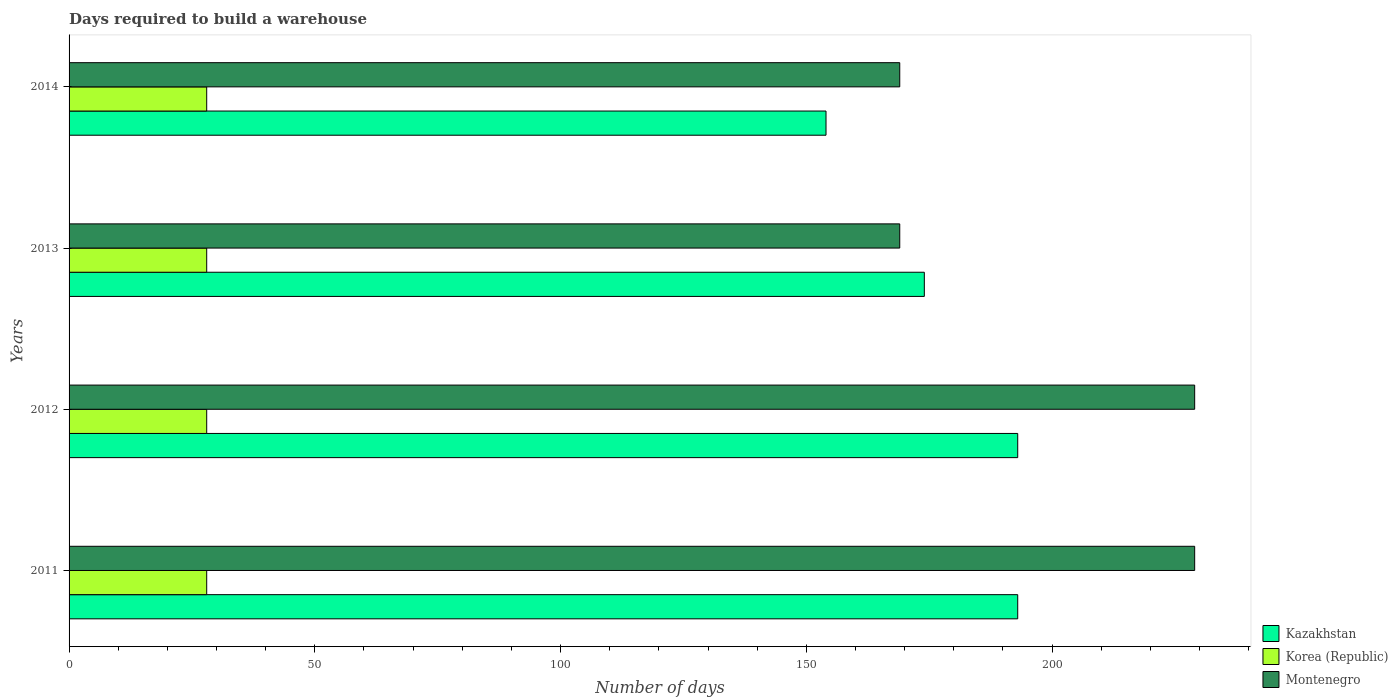Are the number of bars on each tick of the Y-axis equal?
Offer a very short reply. Yes. How many bars are there on the 2nd tick from the bottom?
Your answer should be very brief. 3. What is the label of the 2nd group of bars from the top?
Give a very brief answer. 2013. What is the days required to build a warehouse in in Korea (Republic) in 2014?
Offer a very short reply. 28. Across all years, what is the maximum days required to build a warehouse in in Kazakhstan?
Your response must be concise. 193. Across all years, what is the minimum days required to build a warehouse in in Montenegro?
Make the answer very short. 169. In which year was the days required to build a warehouse in in Kazakhstan maximum?
Ensure brevity in your answer.  2011. What is the total days required to build a warehouse in in Korea (Republic) in the graph?
Your answer should be very brief. 112. What is the difference between the days required to build a warehouse in in Kazakhstan in 2011 and the days required to build a warehouse in in Montenegro in 2013?
Your answer should be compact. 24. What is the average days required to build a warehouse in in Montenegro per year?
Your response must be concise. 199. In the year 2013, what is the difference between the days required to build a warehouse in in Montenegro and days required to build a warehouse in in Korea (Republic)?
Make the answer very short. 141. In how many years, is the days required to build a warehouse in in Korea (Republic) greater than 160 days?
Ensure brevity in your answer.  0. What is the ratio of the days required to build a warehouse in in Kazakhstan in 2012 to that in 2013?
Make the answer very short. 1.11. Is the days required to build a warehouse in in Montenegro in 2012 less than that in 2014?
Provide a succinct answer. No. What is the difference between the highest and the lowest days required to build a warehouse in in Kazakhstan?
Your answer should be very brief. 39. In how many years, is the days required to build a warehouse in in Montenegro greater than the average days required to build a warehouse in in Montenegro taken over all years?
Ensure brevity in your answer.  2. What does the 1st bar from the bottom in 2011 represents?
Give a very brief answer. Kazakhstan. Is it the case that in every year, the sum of the days required to build a warehouse in in Kazakhstan and days required to build a warehouse in in Montenegro is greater than the days required to build a warehouse in in Korea (Republic)?
Offer a very short reply. Yes. How many bars are there?
Ensure brevity in your answer.  12. Are all the bars in the graph horizontal?
Your response must be concise. Yes. Are the values on the major ticks of X-axis written in scientific E-notation?
Ensure brevity in your answer.  No. Does the graph contain any zero values?
Ensure brevity in your answer.  No. How are the legend labels stacked?
Provide a short and direct response. Vertical. What is the title of the graph?
Provide a succinct answer. Days required to build a warehouse. What is the label or title of the X-axis?
Provide a succinct answer. Number of days. What is the Number of days of Kazakhstan in 2011?
Your response must be concise. 193. What is the Number of days in Korea (Republic) in 2011?
Ensure brevity in your answer.  28. What is the Number of days in Montenegro in 2011?
Provide a succinct answer. 229. What is the Number of days in Kazakhstan in 2012?
Offer a terse response. 193. What is the Number of days in Montenegro in 2012?
Offer a terse response. 229. What is the Number of days of Kazakhstan in 2013?
Offer a very short reply. 174. What is the Number of days of Korea (Republic) in 2013?
Your answer should be compact. 28. What is the Number of days in Montenegro in 2013?
Provide a short and direct response. 169. What is the Number of days of Kazakhstan in 2014?
Make the answer very short. 154. What is the Number of days of Korea (Republic) in 2014?
Your answer should be very brief. 28. What is the Number of days of Montenegro in 2014?
Your answer should be very brief. 169. Across all years, what is the maximum Number of days in Kazakhstan?
Ensure brevity in your answer.  193. Across all years, what is the maximum Number of days of Korea (Republic)?
Give a very brief answer. 28. Across all years, what is the maximum Number of days of Montenegro?
Offer a very short reply. 229. Across all years, what is the minimum Number of days in Kazakhstan?
Offer a very short reply. 154. Across all years, what is the minimum Number of days of Korea (Republic)?
Provide a short and direct response. 28. Across all years, what is the minimum Number of days of Montenegro?
Your answer should be compact. 169. What is the total Number of days of Kazakhstan in the graph?
Offer a very short reply. 714. What is the total Number of days of Korea (Republic) in the graph?
Your answer should be very brief. 112. What is the total Number of days in Montenegro in the graph?
Your answer should be compact. 796. What is the difference between the Number of days in Kazakhstan in 2011 and that in 2012?
Offer a terse response. 0. What is the difference between the Number of days of Montenegro in 2011 and that in 2012?
Make the answer very short. 0. What is the difference between the Number of days of Korea (Republic) in 2011 and that in 2013?
Offer a very short reply. 0. What is the difference between the Number of days in Montenegro in 2011 and that in 2013?
Your response must be concise. 60. What is the difference between the Number of days in Montenegro in 2011 and that in 2014?
Ensure brevity in your answer.  60. What is the difference between the Number of days in Montenegro in 2012 and that in 2013?
Give a very brief answer. 60. What is the difference between the Number of days in Kazakhstan in 2012 and that in 2014?
Offer a terse response. 39. What is the difference between the Number of days of Korea (Republic) in 2012 and that in 2014?
Offer a very short reply. 0. What is the difference between the Number of days in Montenegro in 2012 and that in 2014?
Offer a very short reply. 60. What is the difference between the Number of days of Kazakhstan in 2013 and that in 2014?
Offer a terse response. 20. What is the difference between the Number of days of Korea (Republic) in 2013 and that in 2014?
Make the answer very short. 0. What is the difference between the Number of days of Kazakhstan in 2011 and the Number of days of Korea (Republic) in 2012?
Give a very brief answer. 165. What is the difference between the Number of days in Kazakhstan in 2011 and the Number of days in Montenegro in 2012?
Your response must be concise. -36. What is the difference between the Number of days in Korea (Republic) in 2011 and the Number of days in Montenegro in 2012?
Offer a terse response. -201. What is the difference between the Number of days in Kazakhstan in 2011 and the Number of days in Korea (Republic) in 2013?
Offer a very short reply. 165. What is the difference between the Number of days of Korea (Republic) in 2011 and the Number of days of Montenegro in 2013?
Your answer should be very brief. -141. What is the difference between the Number of days of Kazakhstan in 2011 and the Number of days of Korea (Republic) in 2014?
Give a very brief answer. 165. What is the difference between the Number of days of Korea (Republic) in 2011 and the Number of days of Montenegro in 2014?
Your answer should be compact. -141. What is the difference between the Number of days of Kazakhstan in 2012 and the Number of days of Korea (Republic) in 2013?
Your answer should be very brief. 165. What is the difference between the Number of days of Kazakhstan in 2012 and the Number of days of Montenegro in 2013?
Your response must be concise. 24. What is the difference between the Number of days of Korea (Republic) in 2012 and the Number of days of Montenegro in 2013?
Provide a short and direct response. -141. What is the difference between the Number of days of Kazakhstan in 2012 and the Number of days of Korea (Republic) in 2014?
Offer a terse response. 165. What is the difference between the Number of days of Korea (Republic) in 2012 and the Number of days of Montenegro in 2014?
Your response must be concise. -141. What is the difference between the Number of days in Kazakhstan in 2013 and the Number of days in Korea (Republic) in 2014?
Your response must be concise. 146. What is the difference between the Number of days in Kazakhstan in 2013 and the Number of days in Montenegro in 2014?
Your answer should be compact. 5. What is the difference between the Number of days of Korea (Republic) in 2013 and the Number of days of Montenegro in 2014?
Make the answer very short. -141. What is the average Number of days in Kazakhstan per year?
Offer a terse response. 178.5. What is the average Number of days in Korea (Republic) per year?
Give a very brief answer. 28. What is the average Number of days in Montenegro per year?
Provide a succinct answer. 199. In the year 2011, what is the difference between the Number of days of Kazakhstan and Number of days of Korea (Republic)?
Your answer should be very brief. 165. In the year 2011, what is the difference between the Number of days in Kazakhstan and Number of days in Montenegro?
Offer a very short reply. -36. In the year 2011, what is the difference between the Number of days in Korea (Republic) and Number of days in Montenegro?
Your answer should be compact. -201. In the year 2012, what is the difference between the Number of days of Kazakhstan and Number of days of Korea (Republic)?
Offer a terse response. 165. In the year 2012, what is the difference between the Number of days in Kazakhstan and Number of days in Montenegro?
Offer a very short reply. -36. In the year 2012, what is the difference between the Number of days in Korea (Republic) and Number of days in Montenegro?
Your answer should be compact. -201. In the year 2013, what is the difference between the Number of days of Kazakhstan and Number of days of Korea (Republic)?
Your answer should be very brief. 146. In the year 2013, what is the difference between the Number of days in Kazakhstan and Number of days in Montenegro?
Provide a succinct answer. 5. In the year 2013, what is the difference between the Number of days of Korea (Republic) and Number of days of Montenegro?
Keep it short and to the point. -141. In the year 2014, what is the difference between the Number of days of Kazakhstan and Number of days of Korea (Republic)?
Your response must be concise. 126. In the year 2014, what is the difference between the Number of days of Korea (Republic) and Number of days of Montenegro?
Ensure brevity in your answer.  -141. What is the ratio of the Number of days in Kazakhstan in 2011 to that in 2013?
Your answer should be very brief. 1.11. What is the ratio of the Number of days of Montenegro in 2011 to that in 2013?
Offer a terse response. 1.35. What is the ratio of the Number of days in Kazakhstan in 2011 to that in 2014?
Ensure brevity in your answer.  1.25. What is the ratio of the Number of days in Montenegro in 2011 to that in 2014?
Ensure brevity in your answer.  1.35. What is the ratio of the Number of days of Kazakhstan in 2012 to that in 2013?
Provide a succinct answer. 1.11. What is the ratio of the Number of days in Korea (Republic) in 2012 to that in 2013?
Your answer should be very brief. 1. What is the ratio of the Number of days of Montenegro in 2012 to that in 2013?
Your answer should be compact. 1.35. What is the ratio of the Number of days of Kazakhstan in 2012 to that in 2014?
Give a very brief answer. 1.25. What is the ratio of the Number of days in Montenegro in 2012 to that in 2014?
Offer a terse response. 1.35. What is the ratio of the Number of days of Kazakhstan in 2013 to that in 2014?
Offer a very short reply. 1.13. What is the ratio of the Number of days in Montenegro in 2013 to that in 2014?
Offer a very short reply. 1. What is the difference between the highest and the second highest Number of days of Kazakhstan?
Your answer should be very brief. 0. What is the difference between the highest and the lowest Number of days of Kazakhstan?
Your response must be concise. 39. What is the difference between the highest and the lowest Number of days in Montenegro?
Offer a very short reply. 60. 